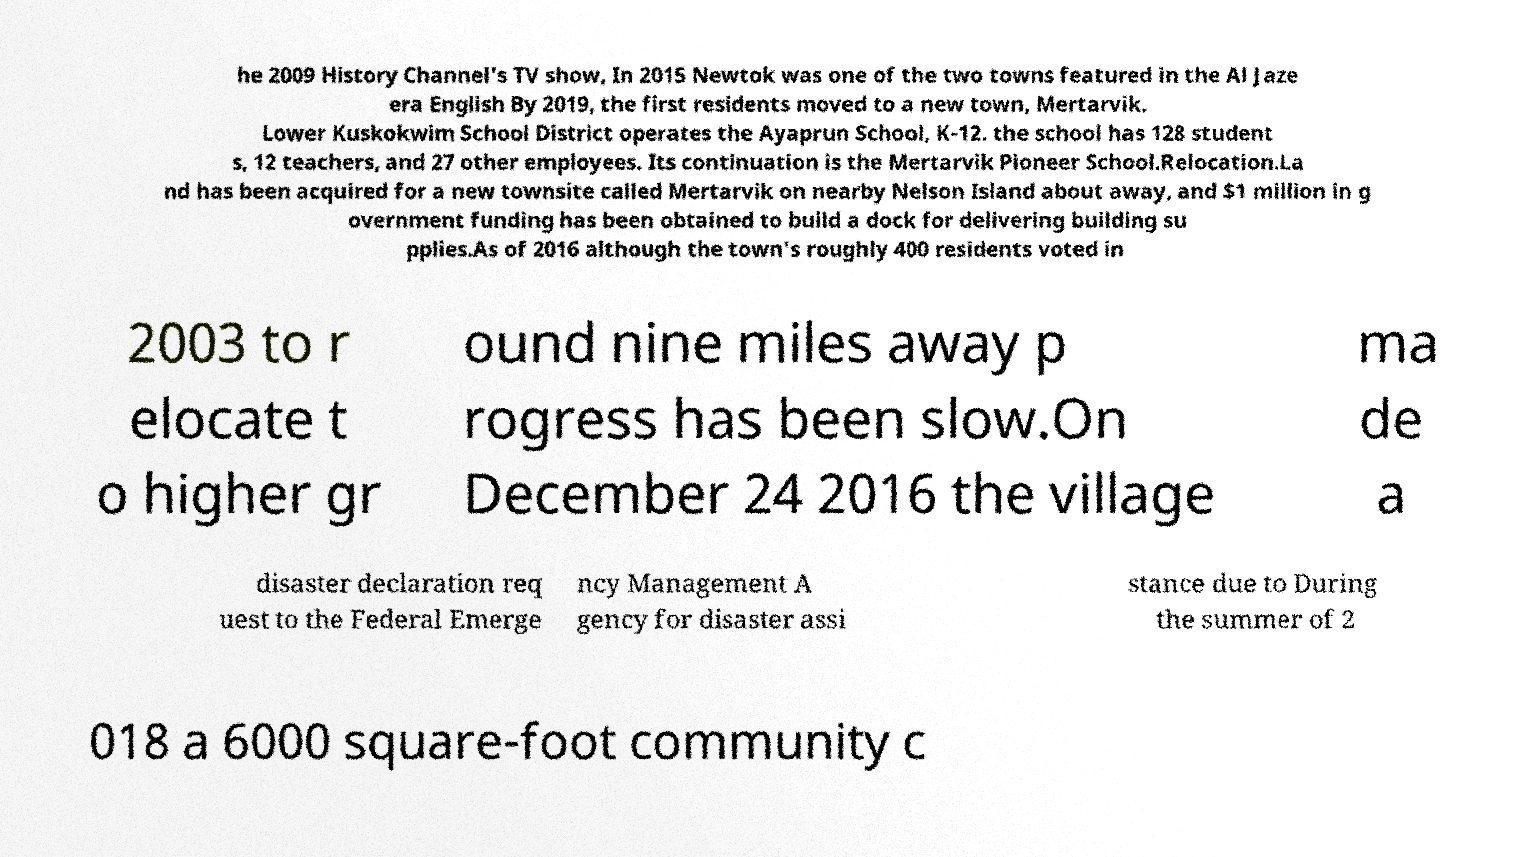Please read and relay the text visible in this image. What does it say? he 2009 History Channel's TV show, In 2015 Newtok was one of the two towns featured in the Al Jaze era English By 2019, the first residents moved to a new town, Mertarvik. Lower Kuskokwim School District operates the Ayaprun School, K-12. the school has 128 student s, 12 teachers, and 27 other employees. Its continuation is the Mertarvik Pioneer School.Relocation.La nd has been acquired for a new townsite called Mertarvik on nearby Nelson Island about away, and $1 million in g overnment funding has been obtained to build a dock for delivering building su pplies.As of 2016 although the town's roughly 400 residents voted in 2003 to r elocate t o higher gr ound nine miles away p rogress has been slow.On December 24 2016 the village ma de a disaster declaration req uest to the Federal Emerge ncy Management A gency for disaster assi stance due to During the summer of 2 018 a 6000 square-foot community c 